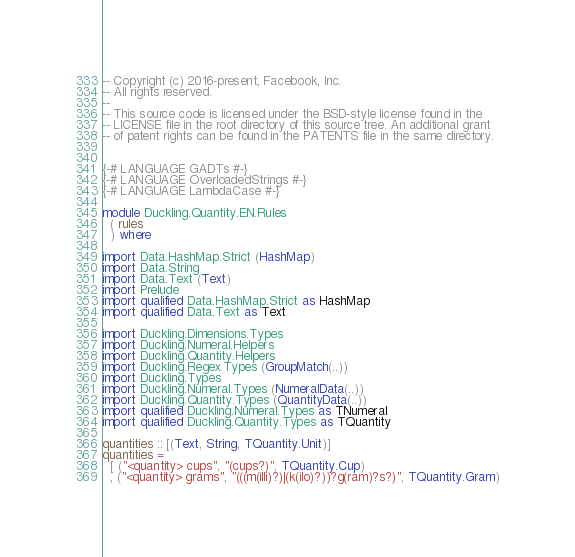Convert code to text. <code><loc_0><loc_0><loc_500><loc_500><_Haskell_>-- Copyright (c) 2016-present, Facebook, Inc.
-- All rights reserved.
--
-- This source code is licensed under the BSD-style license found in the
-- LICENSE file in the root directory of this source tree. An additional grant
-- of patent rights can be found in the PATENTS file in the same directory.


{-# LANGUAGE GADTs #-}
{-# LANGUAGE OverloadedStrings #-}
{-# LANGUAGE LambdaCase #-}

module Duckling.Quantity.EN.Rules
  ( rules
  ) where

import Data.HashMap.Strict (HashMap)
import Data.String
import Data.Text (Text)
import Prelude
import qualified Data.HashMap.Strict as HashMap
import qualified Data.Text as Text

import Duckling.Dimensions.Types
import Duckling.Numeral.Helpers
import Duckling.Quantity.Helpers
import Duckling.Regex.Types (GroupMatch(..))
import Duckling.Types
import Duckling.Numeral.Types (NumeralData(..))
import Duckling.Quantity.Types (QuantityData(..))
import qualified Duckling.Numeral.Types as TNumeral
import qualified Duckling.Quantity.Types as TQuantity

quantities :: [(Text, String, TQuantity.Unit)]
quantities =
  [ ("<quantity> cups", "(cups?)", TQuantity.Cup)
  , ("<quantity> grams", "(((m(illi)?)|(k(ilo)?))?g(ram)?s?)", TQuantity.Gram)</code> 